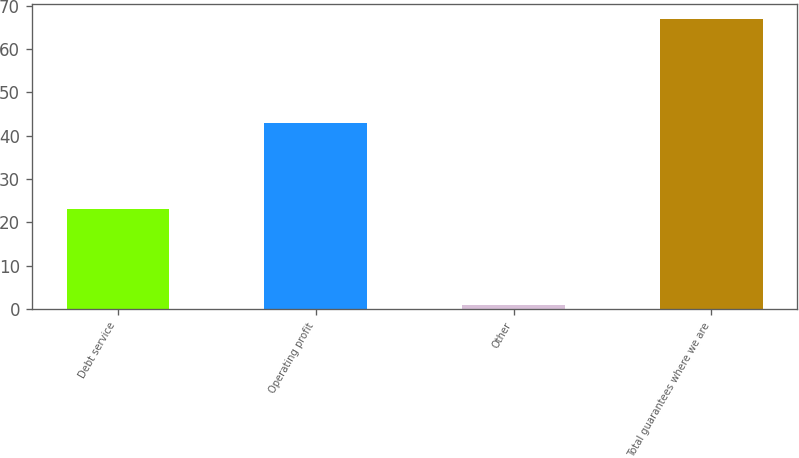Convert chart to OTSL. <chart><loc_0><loc_0><loc_500><loc_500><bar_chart><fcel>Debt service<fcel>Operating profit<fcel>Other<fcel>Total guarantees where we are<nl><fcel>23<fcel>43<fcel>1<fcel>67<nl></chart> 